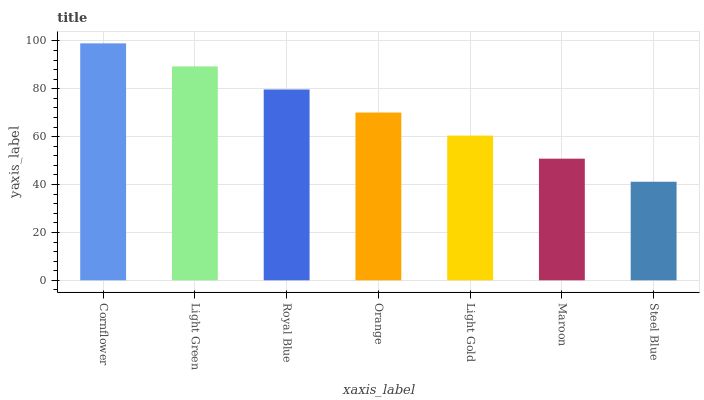Is Steel Blue the minimum?
Answer yes or no. Yes. Is Cornflower the maximum?
Answer yes or no. Yes. Is Light Green the minimum?
Answer yes or no. No. Is Light Green the maximum?
Answer yes or no. No. Is Cornflower greater than Light Green?
Answer yes or no. Yes. Is Light Green less than Cornflower?
Answer yes or no. Yes. Is Light Green greater than Cornflower?
Answer yes or no. No. Is Cornflower less than Light Green?
Answer yes or no. No. Is Orange the high median?
Answer yes or no. Yes. Is Orange the low median?
Answer yes or no. Yes. Is Light Gold the high median?
Answer yes or no. No. Is Royal Blue the low median?
Answer yes or no. No. 